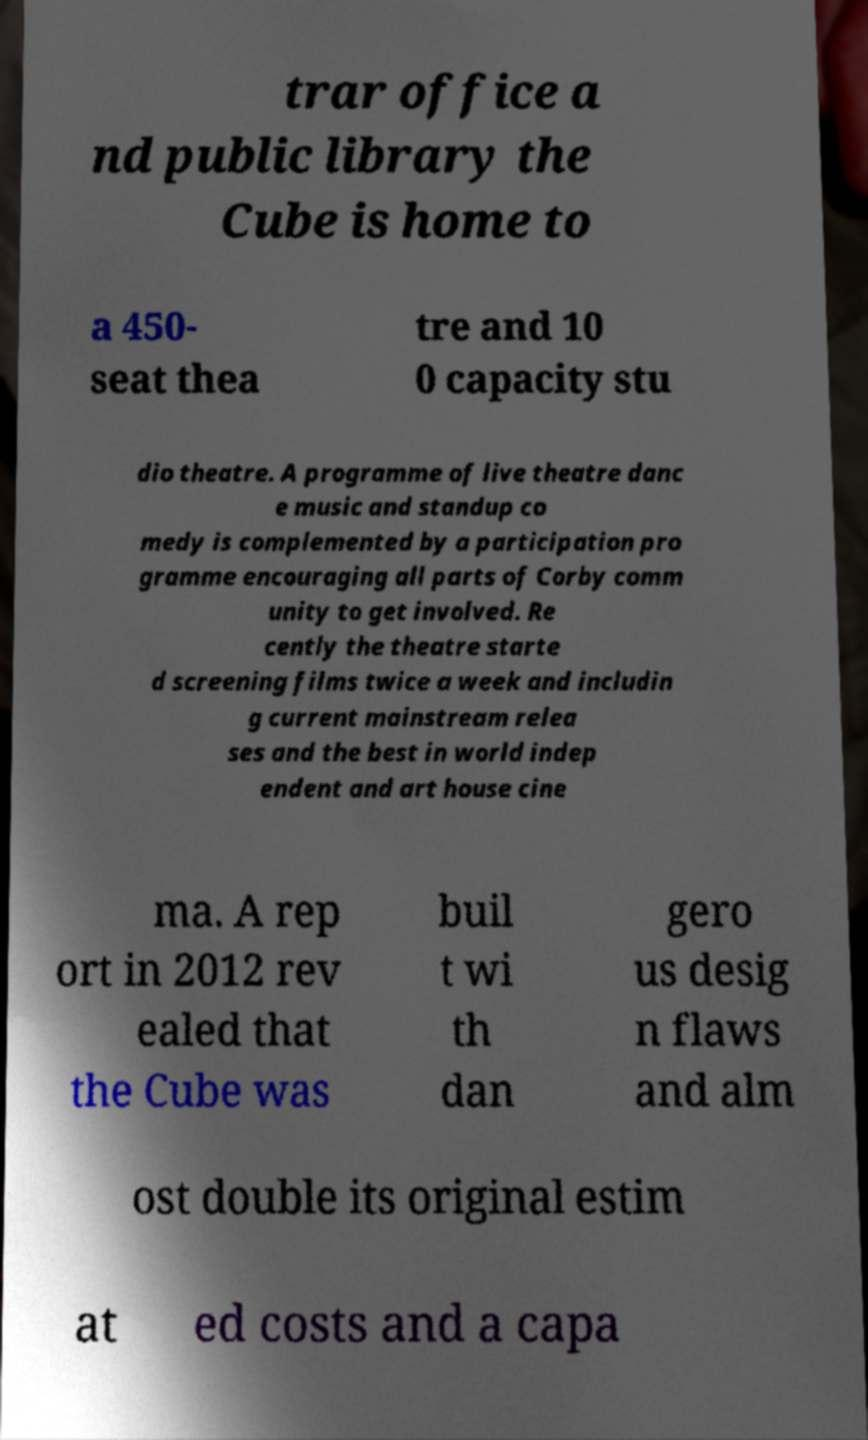Can you read and provide the text displayed in the image?This photo seems to have some interesting text. Can you extract and type it out for me? trar office a nd public library the Cube is home to a 450- seat thea tre and 10 0 capacity stu dio theatre. A programme of live theatre danc e music and standup co medy is complemented by a participation pro gramme encouraging all parts of Corby comm unity to get involved. Re cently the theatre starte d screening films twice a week and includin g current mainstream relea ses and the best in world indep endent and art house cine ma. A rep ort in 2012 rev ealed that the Cube was buil t wi th dan gero us desig n flaws and alm ost double its original estim at ed costs and a capa 